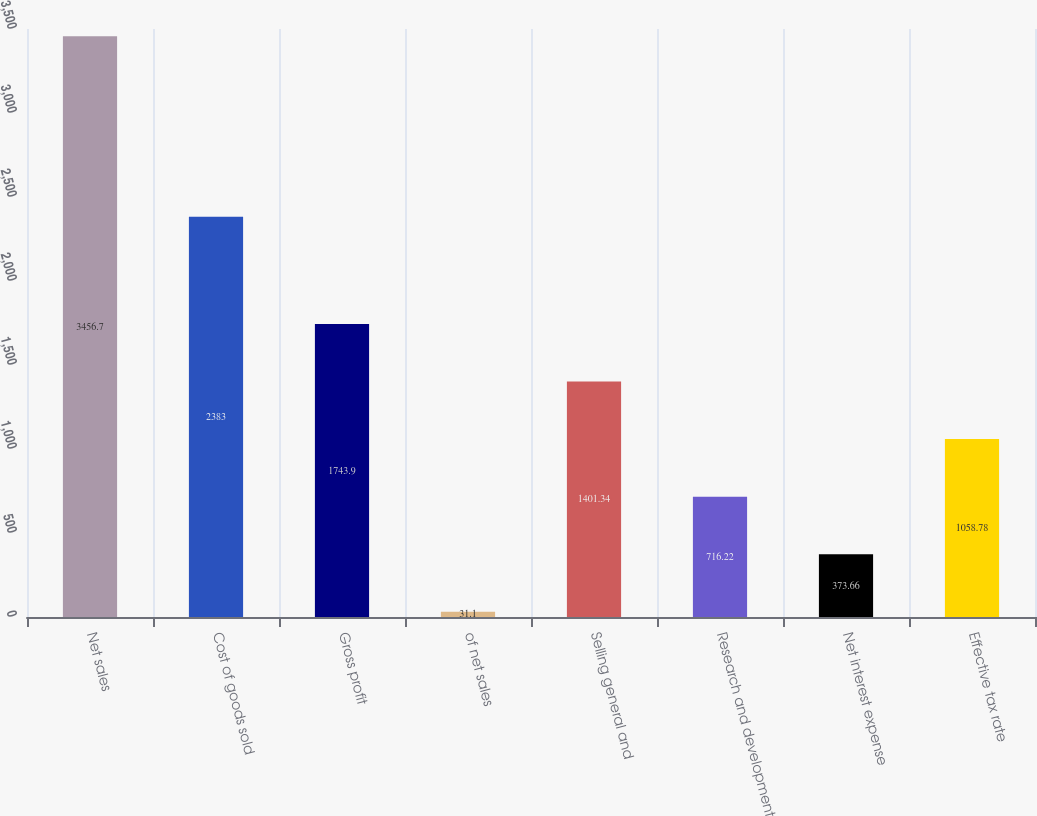<chart> <loc_0><loc_0><loc_500><loc_500><bar_chart><fcel>Net sales<fcel>Cost of goods sold<fcel>Gross profit<fcel>of net sales<fcel>Selling general and<fcel>Research and development<fcel>Net interest expense<fcel>Effective tax rate<nl><fcel>3456.7<fcel>2383<fcel>1743.9<fcel>31.1<fcel>1401.34<fcel>716.22<fcel>373.66<fcel>1058.78<nl></chart> 